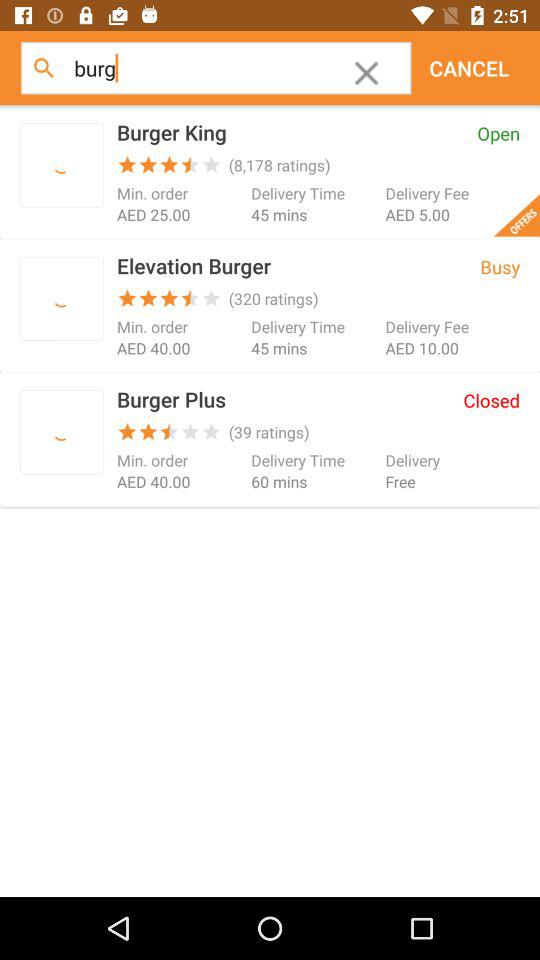What is the minimum order price for "Elevation Burger"? The minimum order price for "Elevation Burger" is AED 40. 